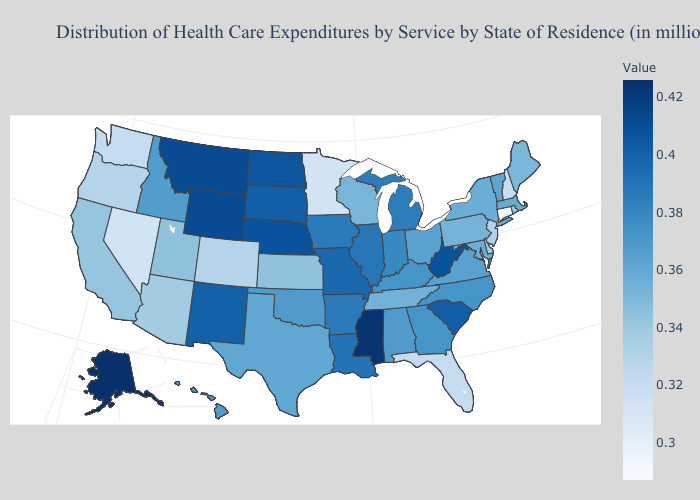Among the states that border Minnesota , does North Dakota have the highest value?
Be succinct. Yes. Does Nebraska have the highest value in the MidWest?
Answer briefly. Yes. Does the map have missing data?
Be succinct. No. Does North Dakota have the highest value in the USA?
Concise answer only. No. Does Texas have the highest value in the South?
Short answer required. No. Does Maine have a higher value than Oregon?
Be succinct. Yes. 